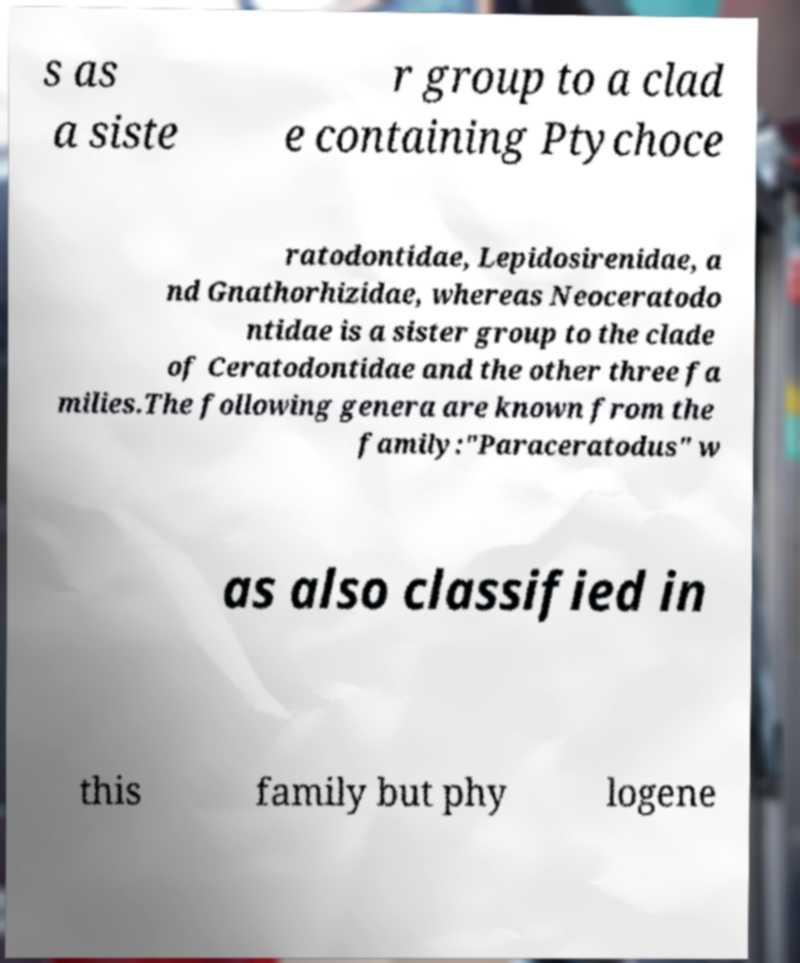Can you accurately transcribe the text from the provided image for me? s as a siste r group to a clad e containing Ptychoce ratodontidae, Lepidosirenidae, a nd Gnathorhizidae, whereas Neoceratodo ntidae is a sister group to the clade of Ceratodontidae and the other three fa milies.The following genera are known from the family:"Paraceratodus" w as also classified in this family but phy logene 